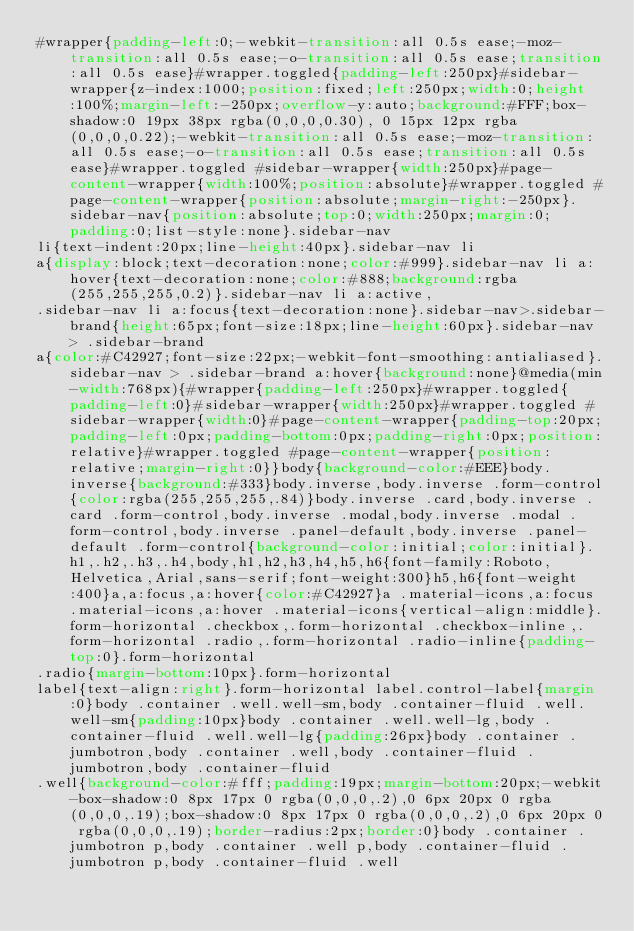<code> <loc_0><loc_0><loc_500><loc_500><_CSS_>#wrapper{padding-left:0;-webkit-transition:all 0.5s ease;-moz-transition:all 0.5s ease;-o-transition:all 0.5s ease;transition:all 0.5s ease}#wrapper.toggled{padding-left:250px}#sidebar-wrapper{z-index:1000;position:fixed;left:250px;width:0;height:100%;margin-left:-250px;overflow-y:auto;background:#FFF;box-shadow:0 19px 38px rgba(0,0,0,0.30), 0 15px 12px rgba(0,0,0,0.22);-webkit-transition:all 0.5s ease;-moz-transition:all 0.5s ease;-o-transition:all 0.5s ease;transition:all 0.5s ease}#wrapper.toggled #sidebar-wrapper{width:250px}#page-content-wrapper{width:100%;position:absolute}#wrapper.toggled #page-content-wrapper{position:absolute;margin-right:-250px}.sidebar-nav{position:absolute;top:0;width:250px;margin:0;padding:0;list-style:none}.sidebar-nav
li{text-indent:20px;line-height:40px}.sidebar-nav li
a{display:block;text-decoration:none;color:#999}.sidebar-nav li a:hover{text-decoration:none;color:#888;background:rgba(255,255,255,0.2)}.sidebar-nav li a:active,
.sidebar-nav li a:focus{text-decoration:none}.sidebar-nav>.sidebar-brand{height:65px;font-size:18px;line-height:60px}.sidebar-nav > .sidebar-brand
a{color:#C42927;font-size:22px;-webkit-font-smoothing:antialiased}.sidebar-nav > .sidebar-brand a:hover{background:none}@media(min-width:768px){#wrapper{padding-left:250px}#wrapper.toggled{padding-left:0}#sidebar-wrapper{width:250px}#wrapper.toggled #sidebar-wrapper{width:0}#page-content-wrapper{padding-top:20px;padding-left:0px;padding-bottom:0px;padding-right:0px;position:relative}#wrapper.toggled #page-content-wrapper{position:relative;margin-right:0}}body{background-color:#EEE}body.inverse{background:#333}body.inverse,body.inverse .form-control{color:rgba(255,255,255,.84)}body.inverse .card,body.inverse .card .form-control,body.inverse .modal,body.inverse .modal .form-control,body.inverse .panel-default,body.inverse .panel-default .form-control{background-color:initial;color:initial}.h1,.h2,.h3,.h4,body,h1,h2,h3,h4,h5,h6{font-family:Roboto,Helvetica,Arial,sans-serif;font-weight:300}h5,h6{font-weight:400}a,a:focus,a:hover{color:#C42927}a .material-icons,a:focus .material-icons,a:hover .material-icons{vertical-align:middle}.form-horizontal .checkbox,.form-horizontal .checkbox-inline,.form-horizontal .radio,.form-horizontal .radio-inline{padding-top:0}.form-horizontal
.radio{margin-bottom:10px}.form-horizontal
label{text-align:right}.form-horizontal label.control-label{margin:0}body .container .well.well-sm,body .container-fluid .well.well-sm{padding:10px}body .container .well.well-lg,body .container-fluid .well.well-lg{padding:26px}body .container .jumbotron,body .container .well,body .container-fluid .jumbotron,body .container-fluid
.well{background-color:#fff;padding:19px;margin-bottom:20px;-webkit-box-shadow:0 8px 17px 0 rgba(0,0,0,.2),0 6px 20px 0 rgba(0,0,0,.19);box-shadow:0 8px 17px 0 rgba(0,0,0,.2),0 6px 20px 0 rgba(0,0,0,.19);border-radius:2px;border:0}body .container .jumbotron p,body .container .well p,body .container-fluid .jumbotron p,body .container-fluid .well</code> 